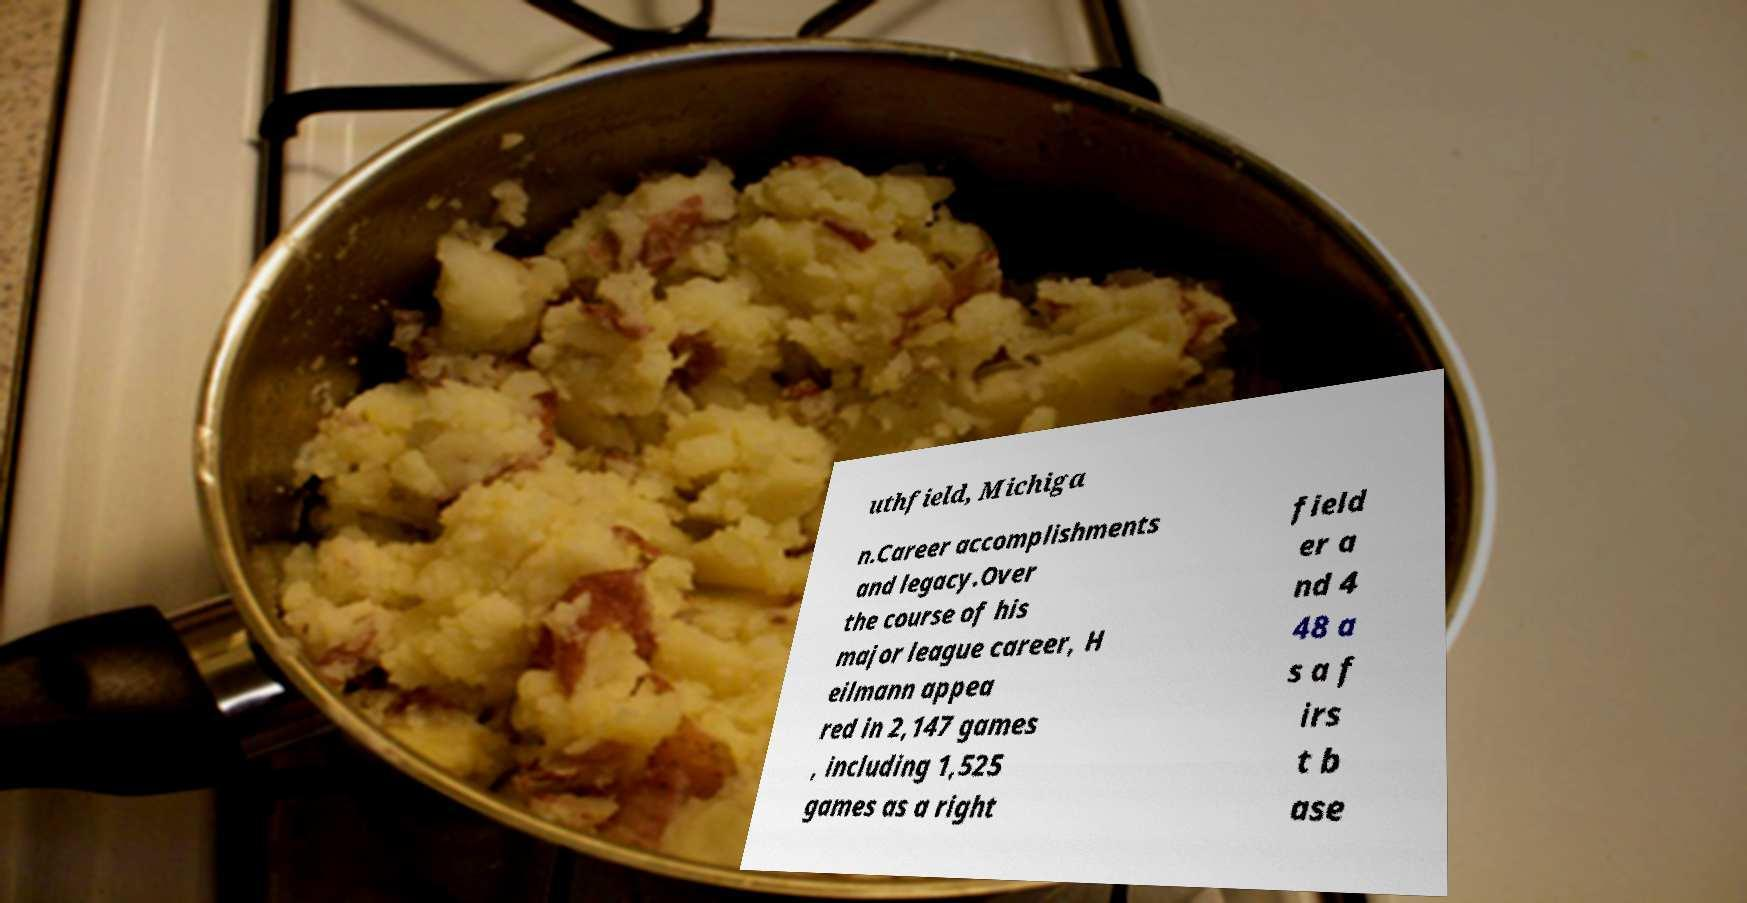Can you accurately transcribe the text from the provided image for me? uthfield, Michiga n.Career accomplishments and legacy.Over the course of his major league career, H eilmann appea red in 2,147 games , including 1,525 games as a right field er a nd 4 48 a s a f irs t b ase 